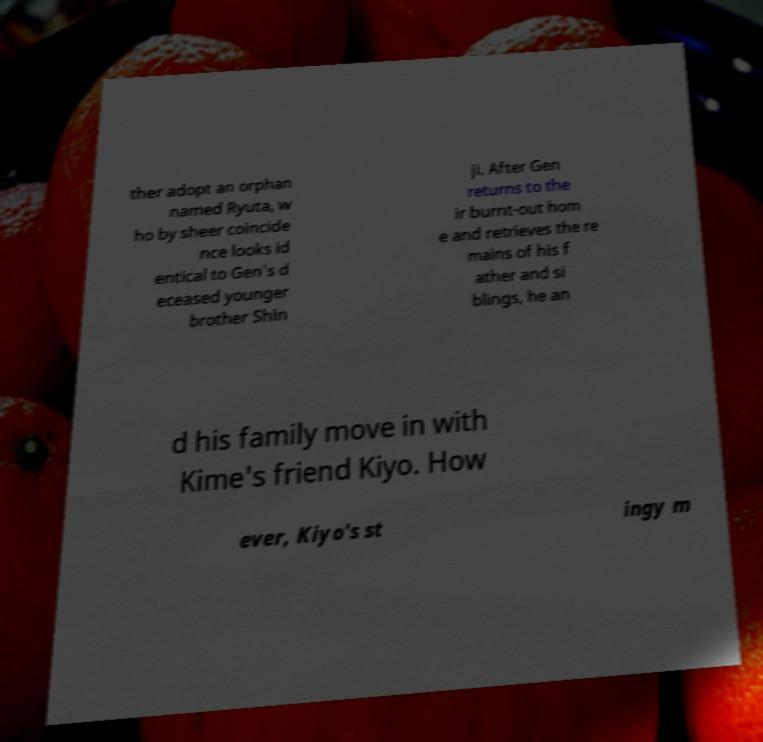Could you extract and type out the text from this image? ther adopt an orphan named Ryuta, w ho by sheer coincide nce looks id entical to Gen's d eceased younger brother Shin ji. After Gen returns to the ir burnt-out hom e and retrieves the re mains of his f ather and si blings, he an d his family move in with Kime's friend Kiyo. How ever, Kiyo's st ingy m 